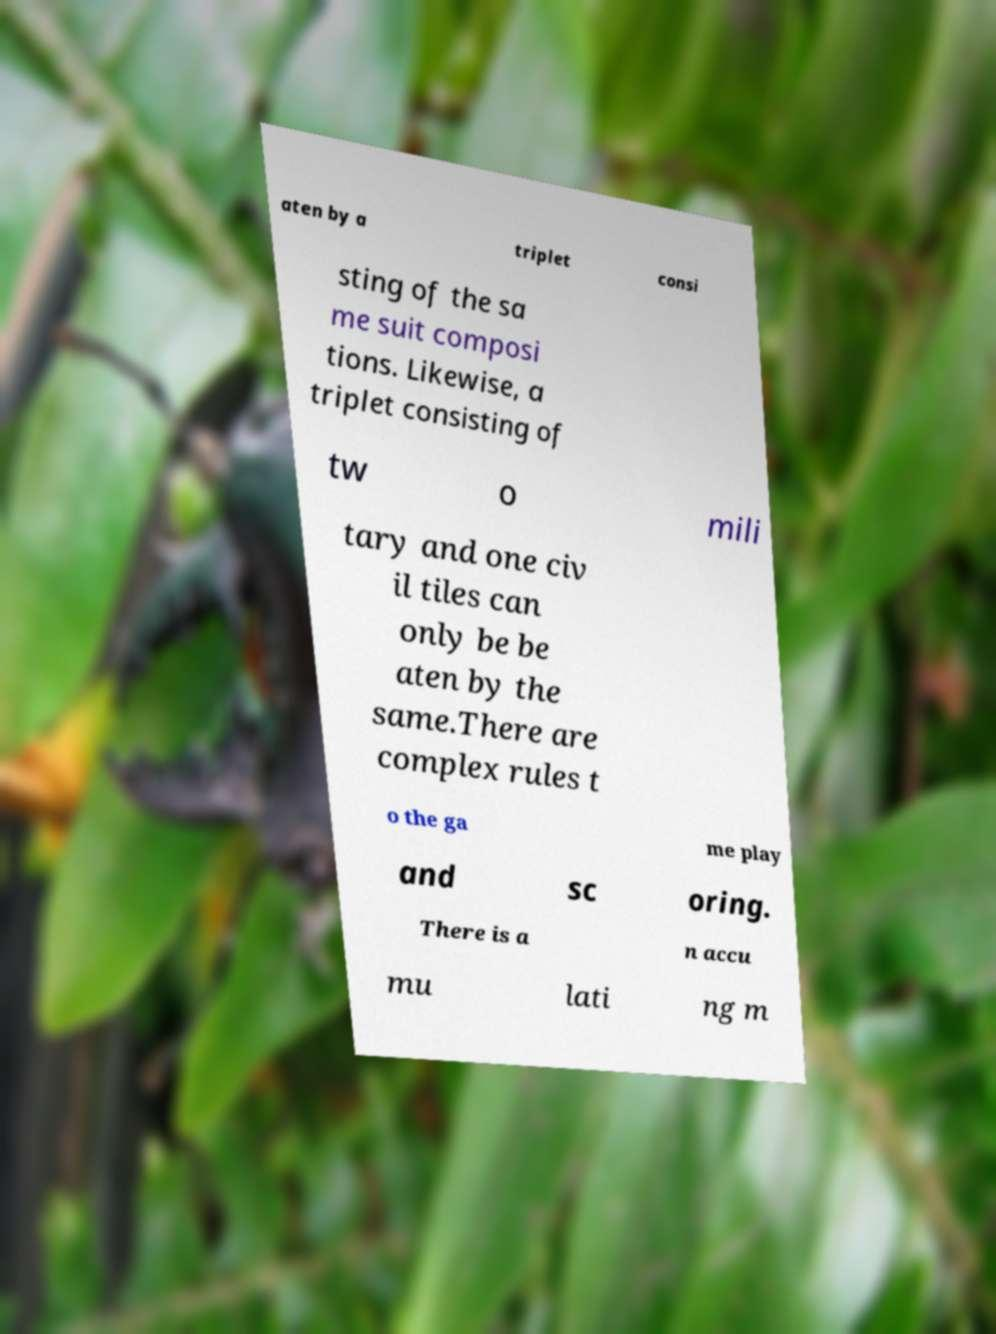There's text embedded in this image that I need extracted. Can you transcribe it verbatim? aten by a triplet consi sting of the sa me suit composi tions. Likewise, a triplet consisting of tw o mili tary and one civ il tiles can only be be aten by the same.There are complex rules t o the ga me play and sc oring. There is a n accu mu lati ng m 